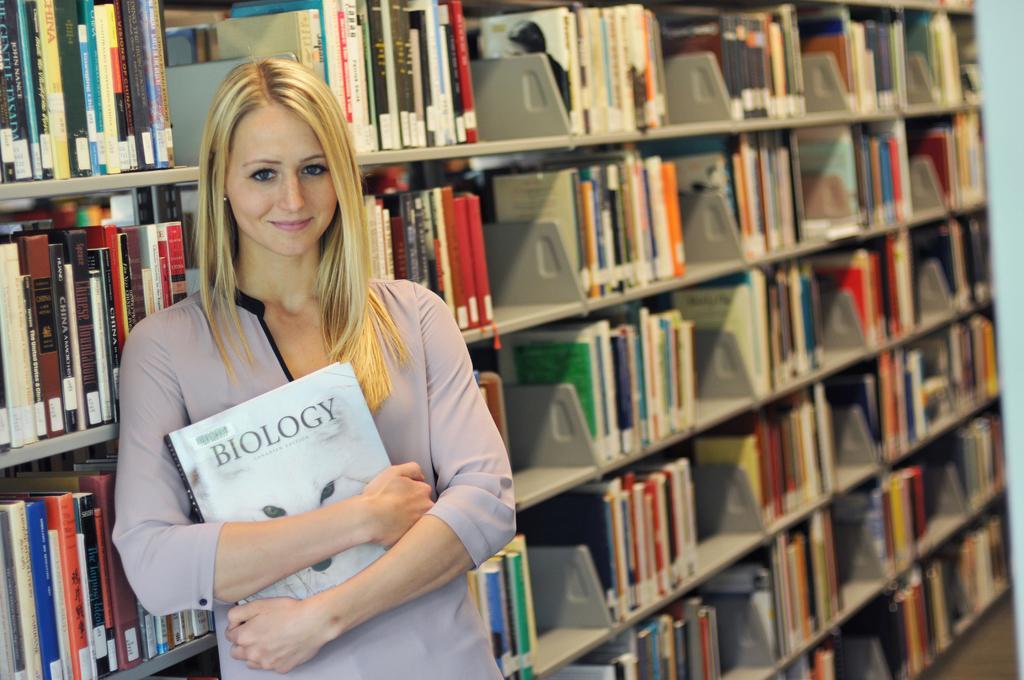Please provide a concise description of this image. In this image we can see one woman standing near the bookshelf and holding a biology book. There is one white object on the floor and bookshelves with a lot of books behind the woman. 